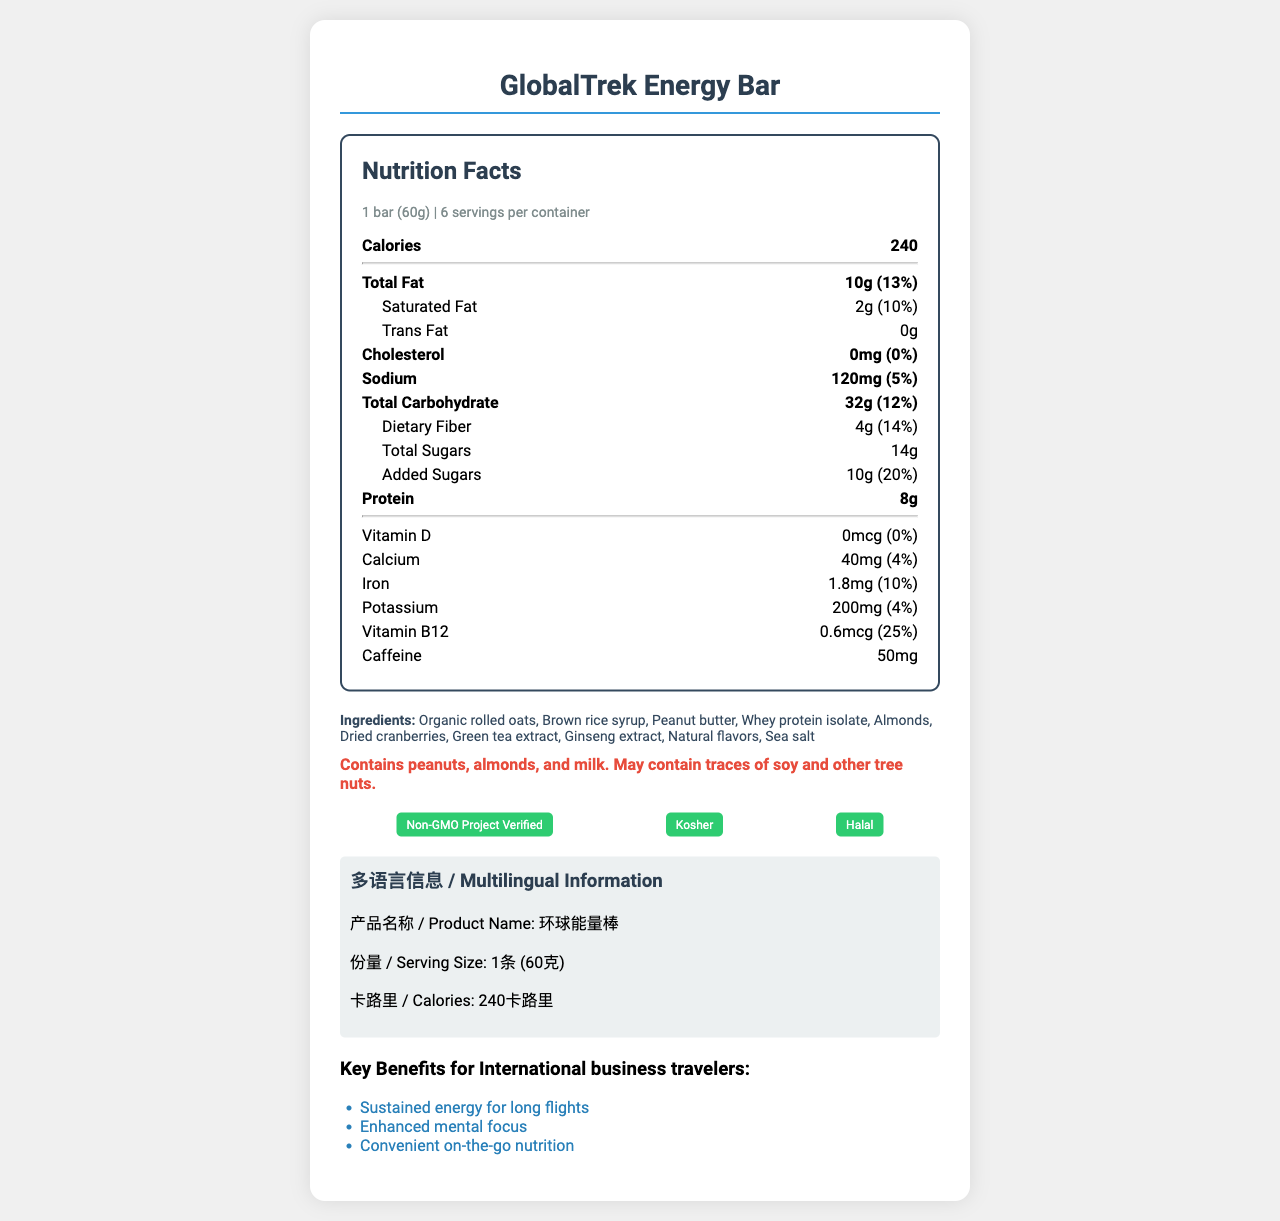what is the serving size? The serving size is clearly listed as "1 bar (60g)" in the nutrition facts section.
Answer: 1 bar (60g) how many calories are in one serving? The nutrition facts section states that one serving contains 240 calories.
Answer: 240 how many servings are in one container? The serving information indicates that there are 6 servings per container.
Answer: 6 how much total fat is in one bar? Under the "Total Fat" row, it specifies that there are 10 grams of total fat per serving.
Answer: 10g how much sodium does one serving contain? The sodium content per serving is listed as 120mg in the nutrition facts section.
Answer: 120mg which ingredient is listed first? The ingredients list starts with "Organic rolled oats."
Answer: Organic rolled oats what vitamins and minerals are included in the nutrition facts? The nutrition facts list Vitamin D, Calcium, Iron, Potassium, and Vitamin B12 along with their amounts and daily values.
Answer: Vitamin D, Calcium, Iron, Potassium, Vitamin B12 what certifications does the product have? A. Non-GMO Project Verified, Kosher, Gluten Free B. Non-GMO Project Verified, Kosher, Halal C. USDA Organic, Kosher, Halal D. Non-GMO Project Verified, Gluten Free, Halal The document lists the product as having "Non-GMO Project Verified," "Kosher," and "Halal" certifications.
Answer: B. Non-GMO Project Verified, Kosher, Halal where is the product made? A. USA B. China C. Germany D. Canada The "origin" information section specifies that the product is made in the USA.
Answer: A. USA does this product contain peanuts? The allergen information specifically indicates that the product contains peanuts.
Answer: Yes summarize the key benefits of the GlobalTrek Energy Bar. The key benefits section lists the benefits as "Sustained energy for long flights," "Enhanced mental focus," and "Convenient on-the-go nutrition."
Answer: Sustained energy for long flights, Enhanced mental focus, Convenient on-the-go nutrition how much caffeine is in one bar? The caffeine content is listed as 50mg in the nutrition facts section.
Answer: 50mg can you find information on the product's storage instructions? The storage information is provided, stating "Store in a cool, dry place. Consume within 7 days of opening."
Answer: Yes is the product non-GMO certified? It is certified "Non-GMO Project Verified," as seen in the certifications section.
Answer: Yes what is the contact email for customer service? The customer service section lists the email as "support@nutriglobal.com."
Answer: support@nutriglobal.com how much iron does one bar contain? The iron content is listed as 1.8mg in the nutrition facts section.
Answer: 1.8mg is this product suitable for consumption by individuals with soy allergies? The allergen information states the product "May contain traces of soy," which suggests it might not be suitable for individuals with soy allergies, but it is not definitive.
Answer: Not enough information 